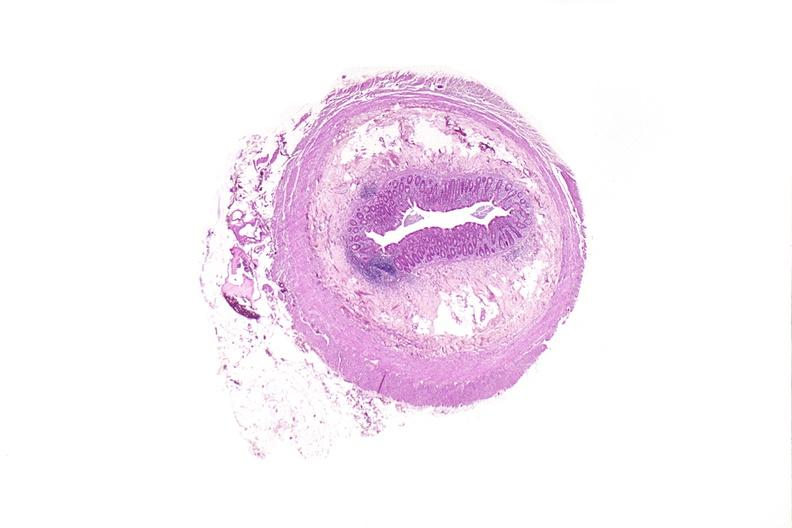does serous cystadenoma show appendix, normal histology?
Answer the question using a single word or phrase. No 